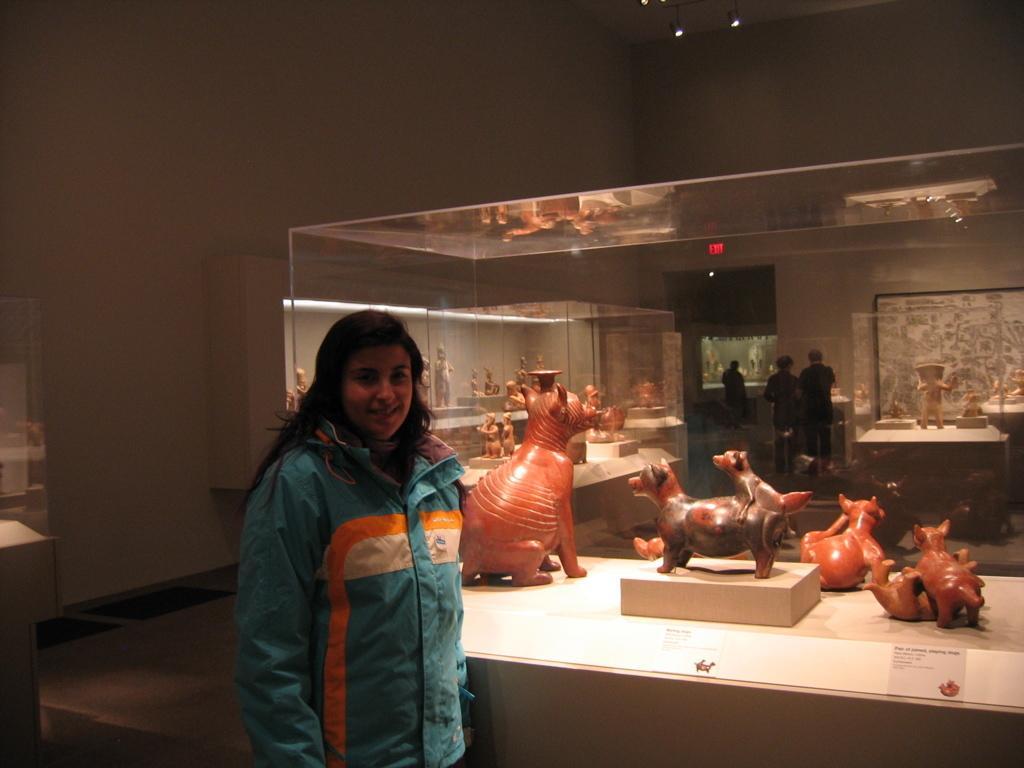Could you give a brief overview of what you see in this image? This image is taken in a museum. In this image there is a woman beside the table with toys. In the background there are three persons visible. There is a plain wall. 